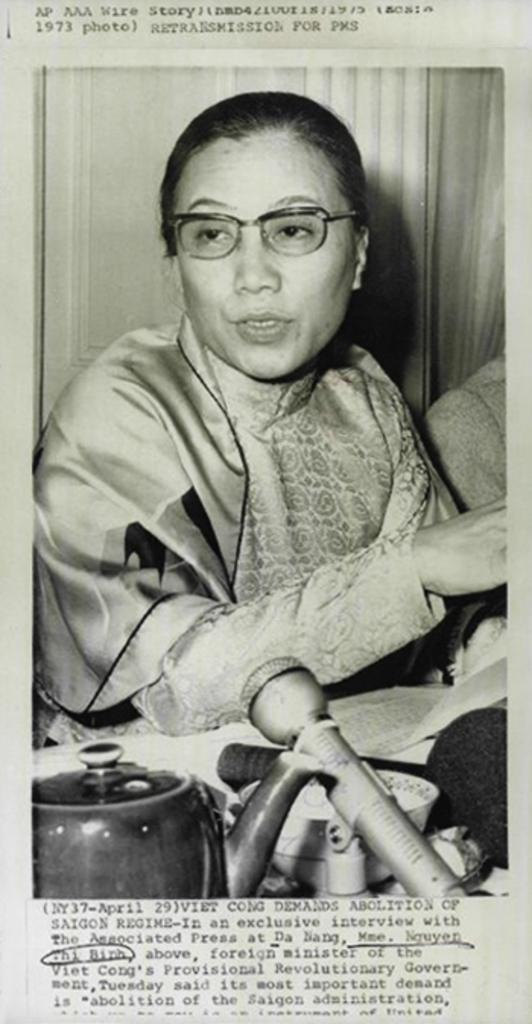What can be seen on the person in the image? The person in the image is wearing spectacles. What object is present for amplifying sound in the image? There is a microphone (mike) in the image. What type of container is visible in the image? There is a bowl in the image. Can you describe any other objects in the image? Yes, there are other objects in the image, but their specific details are not mentioned in the provided facts. What is written on an object in the image? There is text written on an object in the image, but the specific text is not mentioned in the provided facts. What type of arch can be seen in the image? There is no arch present in the image. What is the texture of the low object in the image? There is no low object with a specific texture mentioned in the provided facts. 